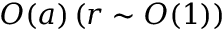Convert formula to latex. <formula><loc_0><loc_0><loc_500><loc_500>O ( a ) \, ( r \sim O ( 1 ) )</formula> 